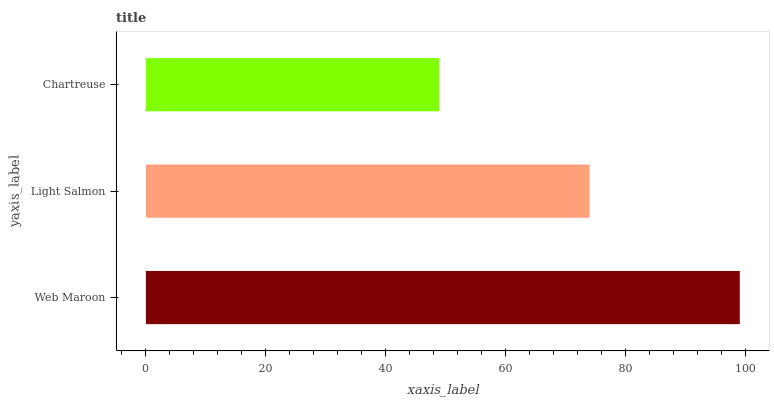Is Chartreuse the minimum?
Answer yes or no. Yes. Is Web Maroon the maximum?
Answer yes or no. Yes. Is Light Salmon the minimum?
Answer yes or no. No. Is Light Salmon the maximum?
Answer yes or no. No. Is Web Maroon greater than Light Salmon?
Answer yes or no. Yes. Is Light Salmon less than Web Maroon?
Answer yes or no. Yes. Is Light Salmon greater than Web Maroon?
Answer yes or no. No. Is Web Maroon less than Light Salmon?
Answer yes or no. No. Is Light Salmon the high median?
Answer yes or no. Yes. Is Light Salmon the low median?
Answer yes or no. Yes. Is Web Maroon the high median?
Answer yes or no. No. Is Chartreuse the low median?
Answer yes or no. No. 